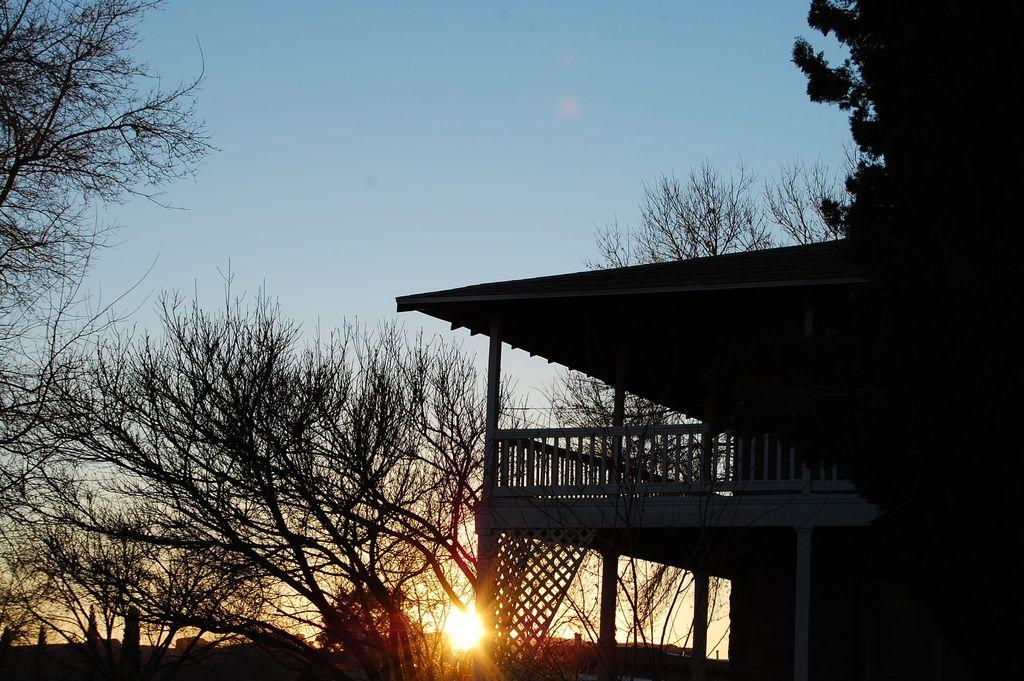What type of vegetation can be seen in the image? There are trees in the image. What celestial body is visible in the image? The sun is visible in the image. Where is the shelter located in the image? The shelter is on the right side of the image. What is visible at the top of the image? The sky is visible at the top of the image. Can you tell me how many oranges are present in the image? There are no oranges or any other fruits mentioned or visible in the image. Is there a girl interacting with the squirrel in the image? There is no girl or squirrel present in the image. 